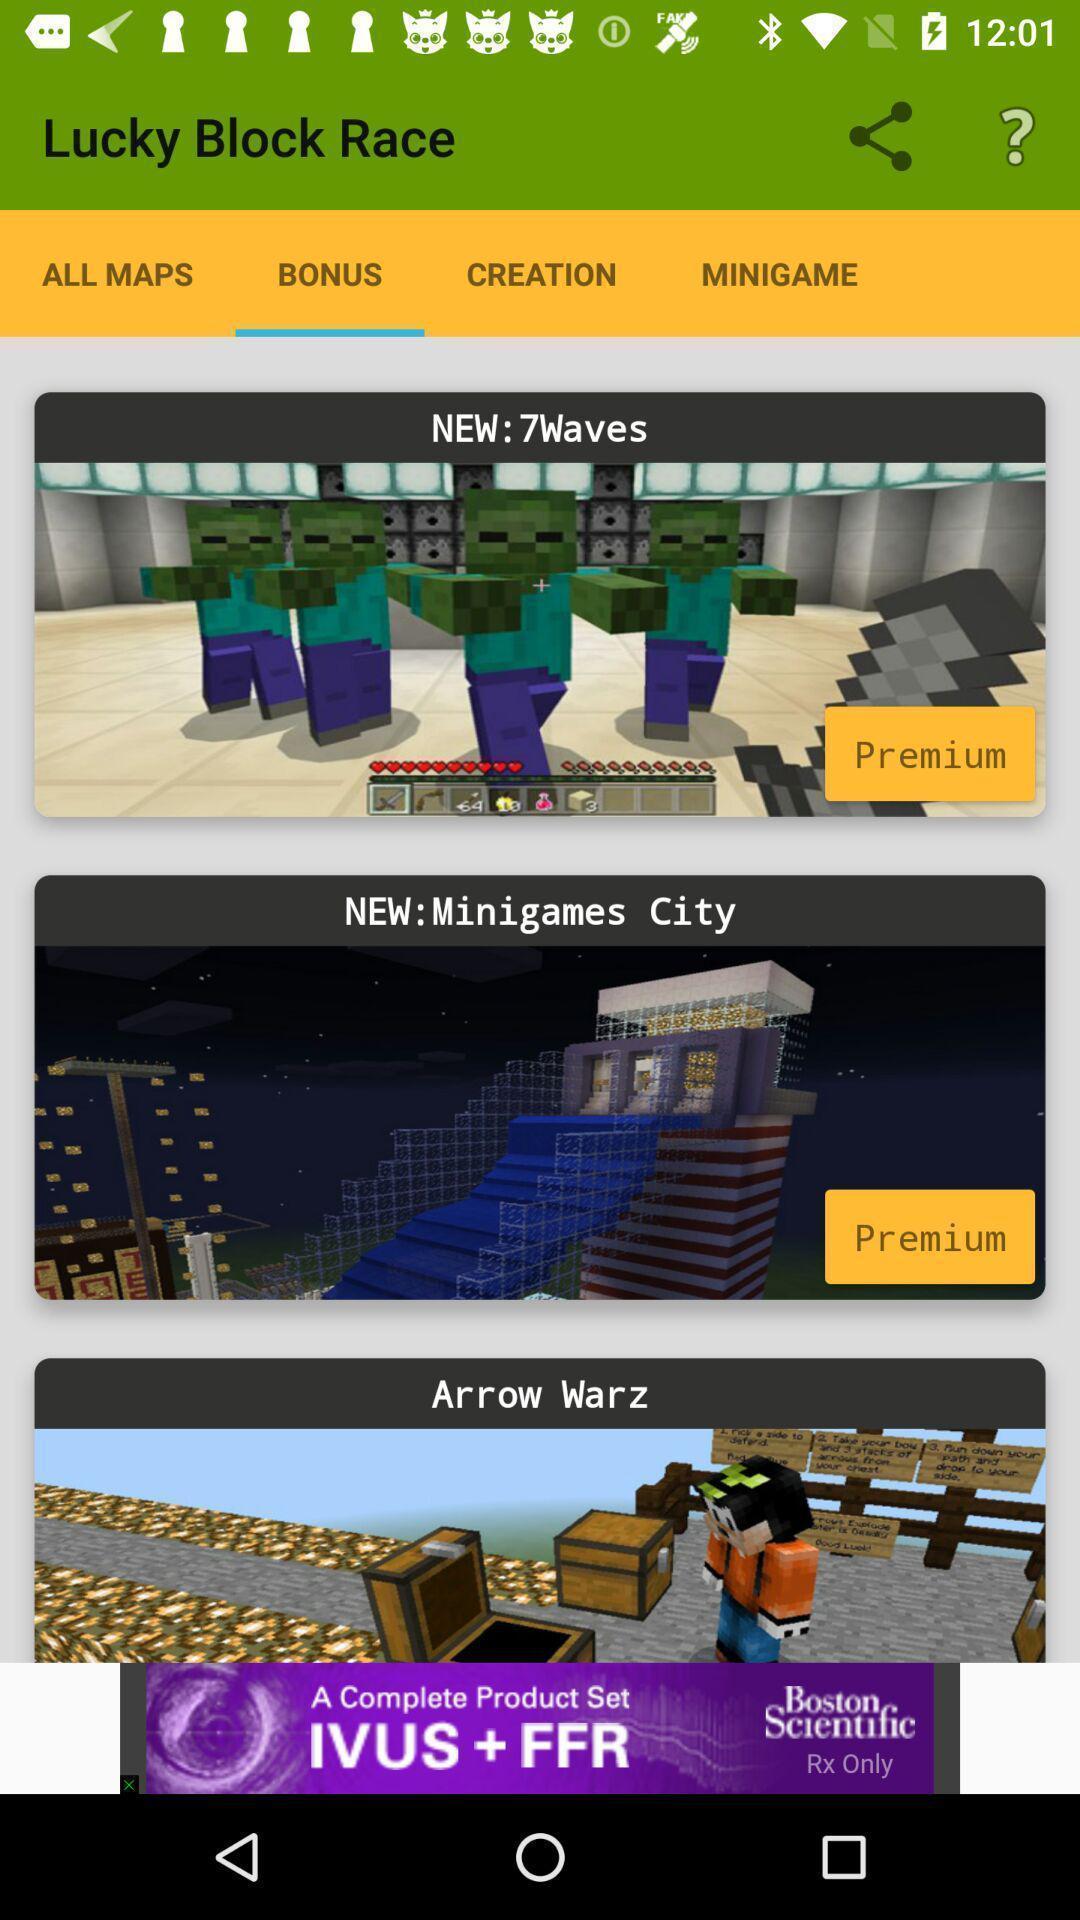Summarize the main components in this picture. Results for bonus. 